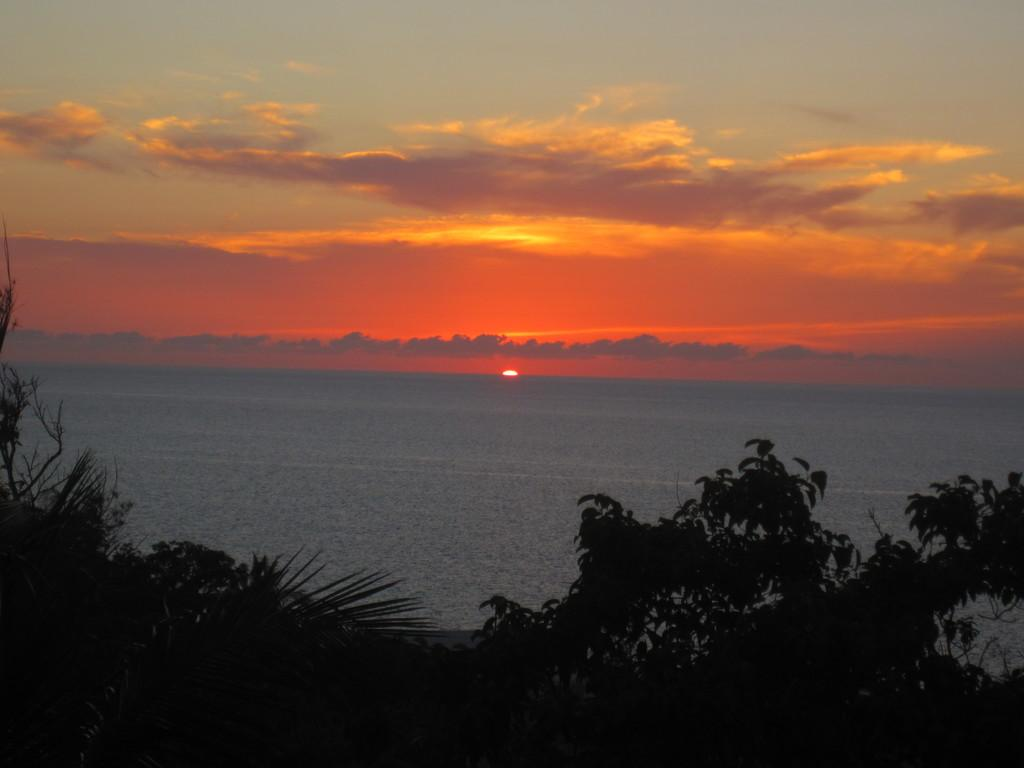What type of vegetation is present at the bottom of the picture? There are trees at the bottom of the picture. What can be seen in the center of the picture? There is a water body in the center of the picture. What celestial body is visible in the background of the picture? The sun is visible in the background of the picture. Can you tell me how many parcels are floating on the water body in the image? There are no parcels present in the image; it features trees at the bottom, a water body in the center, and the sun in the background. What type of paper is used to create the sun in the image? The sun in the image is not a paper representation; it is a celestial body visible in the background. 